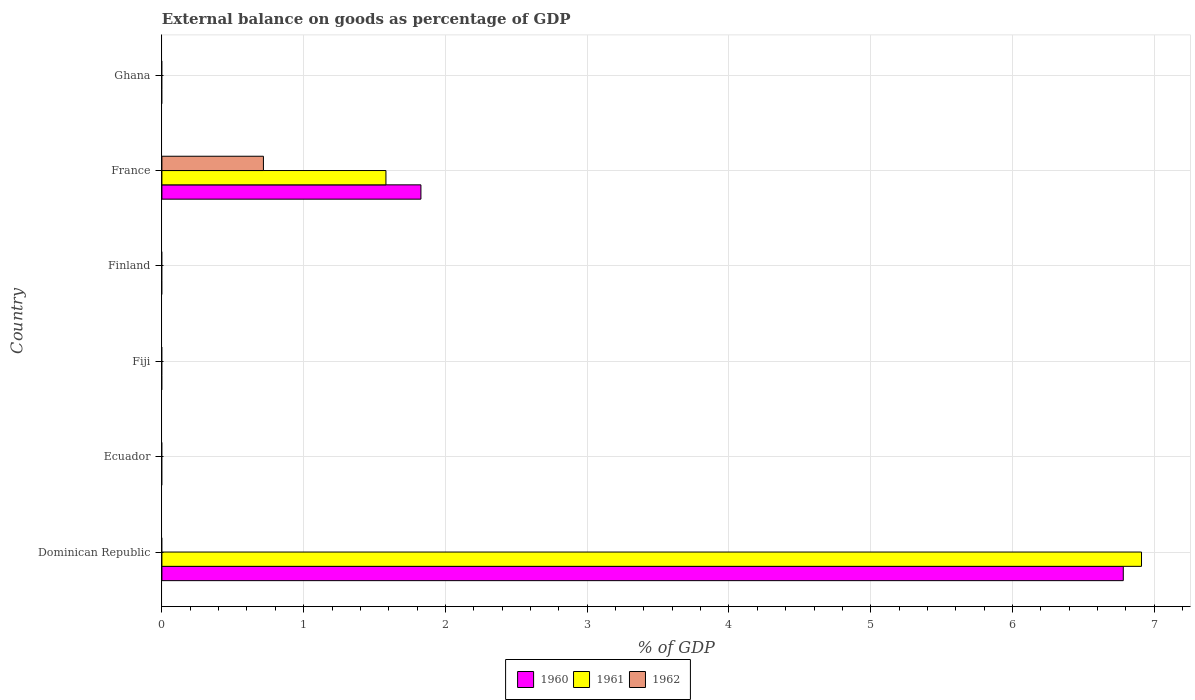How many bars are there on the 1st tick from the top?
Your answer should be compact. 0. How many bars are there on the 3rd tick from the bottom?
Your answer should be very brief. 0. In how many cases, is the number of bars for a given country not equal to the number of legend labels?
Give a very brief answer. 5. Across all countries, what is the maximum external balance on goods as percentage of GDP in 1960?
Ensure brevity in your answer.  6.78. In which country was the external balance on goods as percentage of GDP in 1962 maximum?
Offer a terse response. France. What is the total external balance on goods as percentage of GDP in 1960 in the graph?
Ensure brevity in your answer.  8.61. What is the difference between the external balance on goods as percentage of GDP in 1960 in Dominican Republic and that in France?
Your answer should be compact. 4.95. What is the difference between the external balance on goods as percentage of GDP in 1962 in Ghana and the external balance on goods as percentage of GDP in 1961 in Finland?
Ensure brevity in your answer.  0. What is the average external balance on goods as percentage of GDP in 1961 per country?
Offer a very short reply. 1.42. What is the difference between the external balance on goods as percentage of GDP in 1962 and external balance on goods as percentage of GDP in 1961 in France?
Your answer should be compact. -0.86. What is the difference between the highest and the lowest external balance on goods as percentage of GDP in 1960?
Your answer should be compact. 6.78. In how many countries, is the external balance on goods as percentage of GDP in 1961 greater than the average external balance on goods as percentage of GDP in 1961 taken over all countries?
Offer a very short reply. 2. Is it the case that in every country, the sum of the external balance on goods as percentage of GDP in 1960 and external balance on goods as percentage of GDP in 1962 is greater than the external balance on goods as percentage of GDP in 1961?
Your answer should be compact. No. How many bars are there?
Your response must be concise. 5. Are all the bars in the graph horizontal?
Provide a succinct answer. Yes. What is the difference between two consecutive major ticks on the X-axis?
Keep it short and to the point. 1. Are the values on the major ticks of X-axis written in scientific E-notation?
Make the answer very short. No. Does the graph contain any zero values?
Provide a short and direct response. Yes. Does the graph contain grids?
Your answer should be very brief. Yes. How are the legend labels stacked?
Keep it short and to the point. Horizontal. What is the title of the graph?
Give a very brief answer. External balance on goods as percentage of GDP. Does "2014" appear as one of the legend labels in the graph?
Your response must be concise. No. What is the label or title of the X-axis?
Your answer should be compact. % of GDP. What is the label or title of the Y-axis?
Provide a short and direct response. Country. What is the % of GDP of 1960 in Dominican Republic?
Provide a short and direct response. 6.78. What is the % of GDP in 1961 in Dominican Republic?
Provide a short and direct response. 6.91. What is the % of GDP of 1962 in Ecuador?
Provide a short and direct response. 0. What is the % of GDP of 1961 in Fiji?
Your answer should be very brief. 0. What is the % of GDP of 1962 in Fiji?
Keep it short and to the point. 0. What is the % of GDP in 1960 in France?
Ensure brevity in your answer.  1.83. What is the % of GDP in 1961 in France?
Keep it short and to the point. 1.58. What is the % of GDP of 1962 in France?
Your answer should be very brief. 0.72. What is the % of GDP of 1961 in Ghana?
Your answer should be very brief. 0. Across all countries, what is the maximum % of GDP in 1960?
Your answer should be very brief. 6.78. Across all countries, what is the maximum % of GDP of 1961?
Your answer should be compact. 6.91. Across all countries, what is the maximum % of GDP in 1962?
Offer a terse response. 0.72. Across all countries, what is the minimum % of GDP of 1960?
Your response must be concise. 0. Across all countries, what is the minimum % of GDP of 1962?
Your answer should be very brief. 0. What is the total % of GDP in 1960 in the graph?
Offer a very short reply. 8.61. What is the total % of GDP of 1961 in the graph?
Make the answer very short. 8.49. What is the total % of GDP in 1962 in the graph?
Ensure brevity in your answer.  0.72. What is the difference between the % of GDP of 1960 in Dominican Republic and that in France?
Make the answer very short. 4.95. What is the difference between the % of GDP of 1961 in Dominican Republic and that in France?
Keep it short and to the point. 5.33. What is the difference between the % of GDP in 1960 in Dominican Republic and the % of GDP in 1961 in France?
Keep it short and to the point. 5.2. What is the difference between the % of GDP in 1960 in Dominican Republic and the % of GDP in 1962 in France?
Your answer should be compact. 6.07. What is the difference between the % of GDP of 1961 in Dominican Republic and the % of GDP of 1962 in France?
Keep it short and to the point. 6.19. What is the average % of GDP in 1960 per country?
Offer a terse response. 1.43. What is the average % of GDP in 1961 per country?
Your answer should be compact. 1.42. What is the average % of GDP in 1962 per country?
Give a very brief answer. 0.12. What is the difference between the % of GDP of 1960 and % of GDP of 1961 in Dominican Republic?
Offer a very short reply. -0.13. What is the difference between the % of GDP in 1960 and % of GDP in 1961 in France?
Your answer should be compact. 0.25. What is the difference between the % of GDP in 1960 and % of GDP in 1962 in France?
Offer a terse response. 1.11. What is the difference between the % of GDP in 1961 and % of GDP in 1962 in France?
Your answer should be compact. 0.86. What is the ratio of the % of GDP in 1960 in Dominican Republic to that in France?
Your answer should be very brief. 3.71. What is the ratio of the % of GDP in 1961 in Dominican Republic to that in France?
Offer a very short reply. 4.37. What is the difference between the highest and the lowest % of GDP of 1960?
Offer a very short reply. 6.78. What is the difference between the highest and the lowest % of GDP of 1961?
Offer a very short reply. 6.91. What is the difference between the highest and the lowest % of GDP in 1962?
Give a very brief answer. 0.72. 